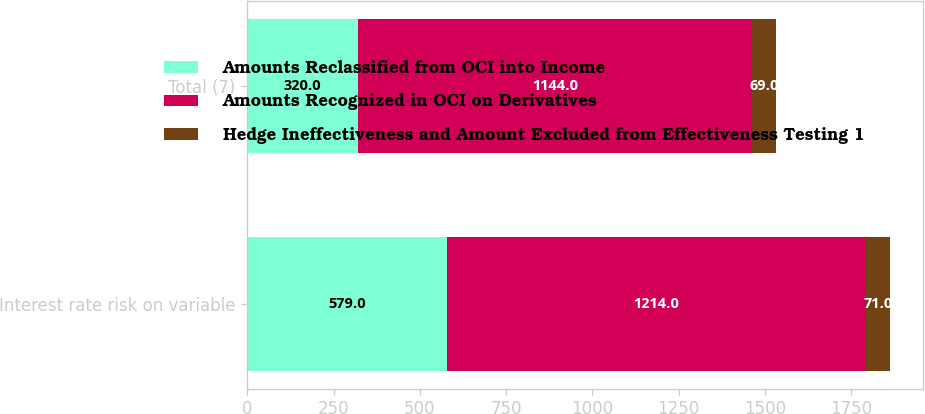Convert chart to OTSL. <chart><loc_0><loc_0><loc_500><loc_500><stacked_bar_chart><ecel><fcel>Interest rate risk on variable<fcel>Total (7)<nl><fcel>Amounts Reclassified from OCI into Income<fcel>579<fcel>320<nl><fcel>Amounts Recognized in OCI on Derivatives<fcel>1214<fcel>1144<nl><fcel>Hedge Ineffectiveness and Amount Excluded from Effectiveness Testing 1<fcel>71<fcel>69<nl></chart> 